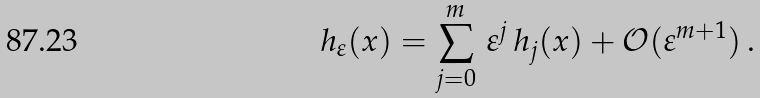<formula> <loc_0><loc_0><loc_500><loc_500>h _ { \varepsilon } ( x ) = \sum _ { j = 0 } ^ { m } \, \varepsilon ^ { j } \, h _ { j } ( x ) + { \mathcal { O } } ( \varepsilon ^ { m + 1 } ) \, .</formula> 